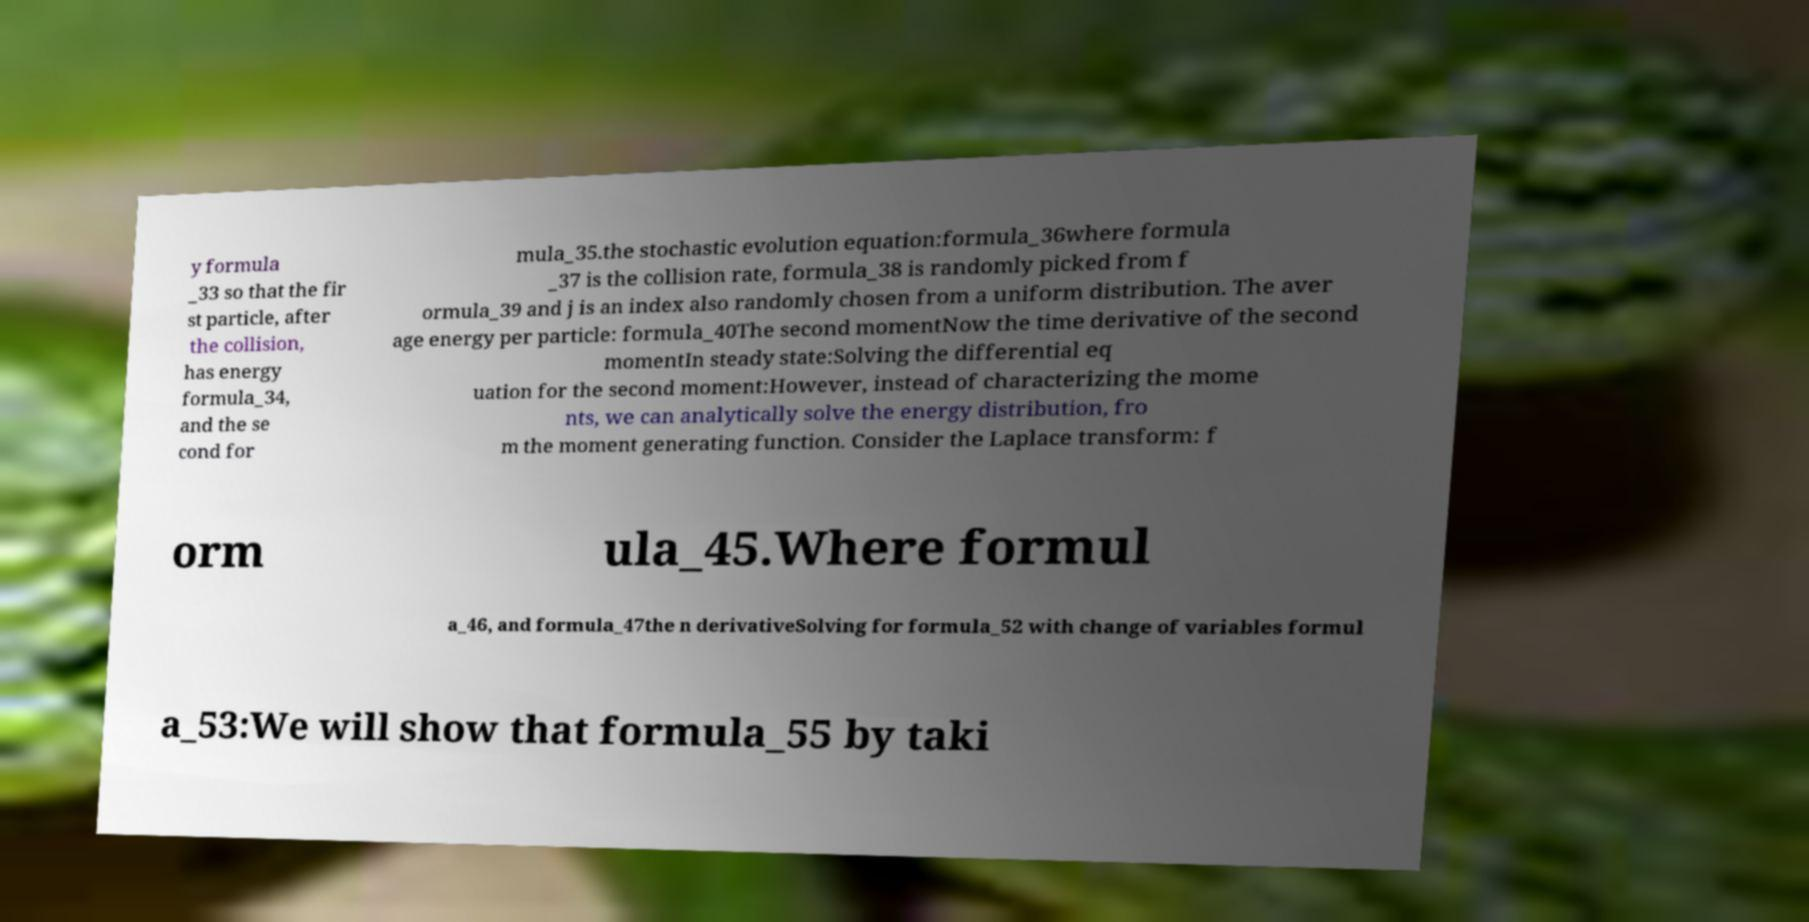There's text embedded in this image that I need extracted. Can you transcribe it verbatim? y formula _33 so that the fir st particle, after the collision, has energy formula_34, and the se cond for mula_35.the stochastic evolution equation:formula_36where formula _37 is the collision rate, formula_38 is randomly picked from f ormula_39 and j is an index also randomly chosen from a uniform distribution. The aver age energy per particle: formula_40The second momentNow the time derivative of the second momentIn steady state:Solving the differential eq uation for the second moment:However, instead of characterizing the mome nts, we can analytically solve the energy distribution, fro m the moment generating function. Consider the Laplace transform: f orm ula_45.Where formul a_46, and formula_47the n derivativeSolving for formula_52 with change of variables formul a_53:We will show that formula_55 by taki 